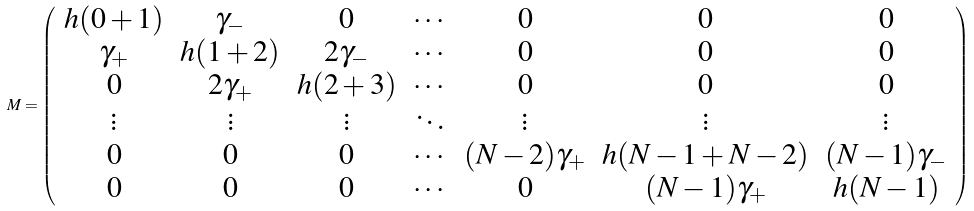Convert formula to latex. <formula><loc_0><loc_0><loc_500><loc_500>M = \left ( \begin{array} { c c c c c c c } h ( 0 + 1 ) & \gamma _ { - } & 0 & \cdots & 0 & 0 & 0 \\ \gamma _ { + } & h ( 1 + 2 ) & 2 \gamma _ { - } & \cdots & 0 & 0 & 0 \\ 0 & 2 \gamma _ { + } & h ( 2 + 3 ) & \cdots & 0 & 0 & 0 \\ \vdots & \vdots & \vdots & \ddots & \vdots & \vdots & \vdots \\ 0 & 0 & 0 & \cdots & ( N - 2 ) \gamma _ { + } & h ( N - 1 + N - 2 ) & ( N - 1 ) \gamma _ { - } \\ 0 & 0 & 0 & \cdots & 0 & ( N - 1 ) \gamma _ { + } & h ( N - 1 ) \\ \end{array} \right )</formula> 